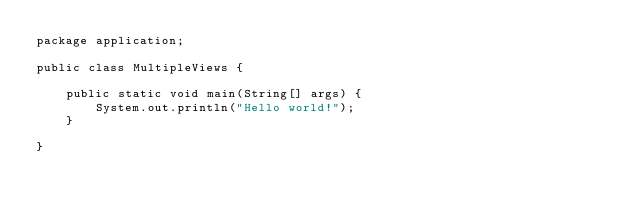<code> <loc_0><loc_0><loc_500><loc_500><_Java_>package application;

public class MultipleViews {

    public static void main(String[] args) {
        System.out.println("Hello world!");
    }

}
</code> 